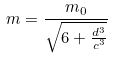<formula> <loc_0><loc_0><loc_500><loc_500>m = \frac { m _ { 0 } } { \sqrt { 6 + \frac { d ^ { 3 } } { c ^ { 3 } } } }</formula> 